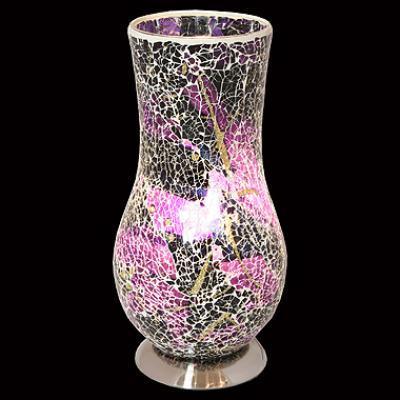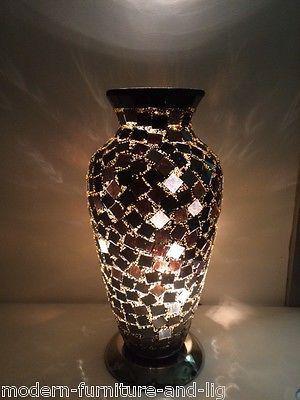The first image is the image on the left, the second image is the image on the right. Given the left and right images, does the statement "A vase is displayed against a plain black background." hold true? Answer yes or no. Yes. The first image is the image on the left, the second image is the image on the right. Evaluate the accuracy of this statement regarding the images: "One lamp is shaped like an urn with a solid black base, while a second lamp has a rounded lower half that narrows before flaring slightly at the top, and sits on a silver base.". Is it true? Answer yes or no. Yes. 